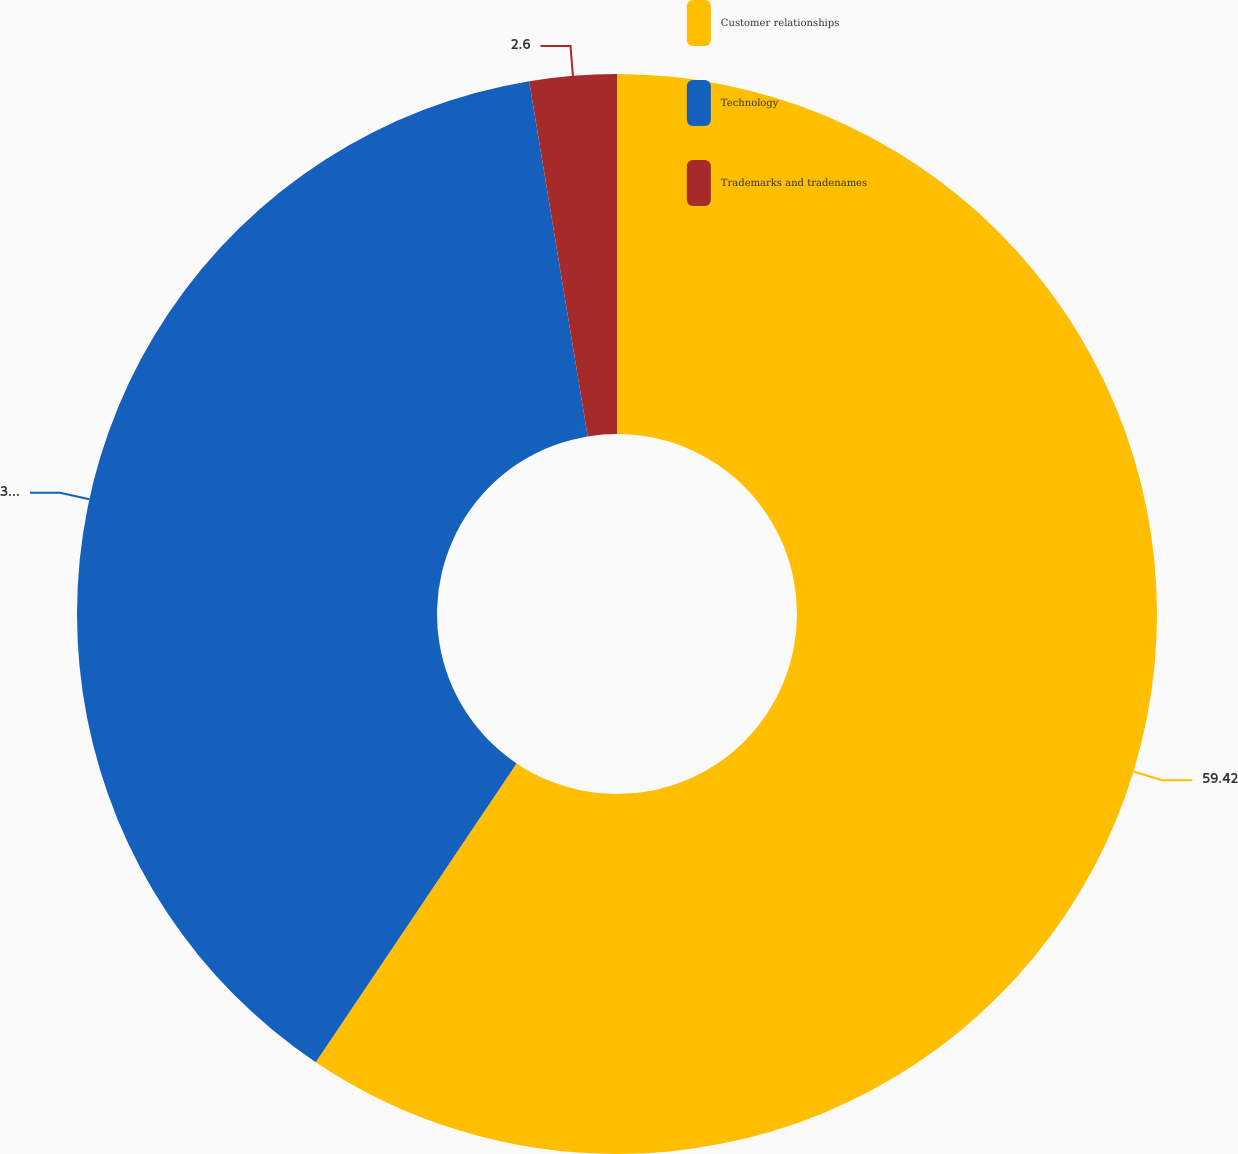Convert chart. <chart><loc_0><loc_0><loc_500><loc_500><pie_chart><fcel>Customer relationships<fcel>Technology<fcel>Trademarks and tradenames<nl><fcel>59.42%<fcel>37.98%<fcel>2.6%<nl></chart> 